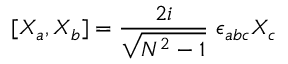<formula> <loc_0><loc_0><loc_500><loc_500>[ X _ { a } , X _ { b } ] = \frac { 2 i } { \sqrt { N ^ { 2 } - 1 } } \ \epsilon _ { a b c } X _ { c }</formula> 